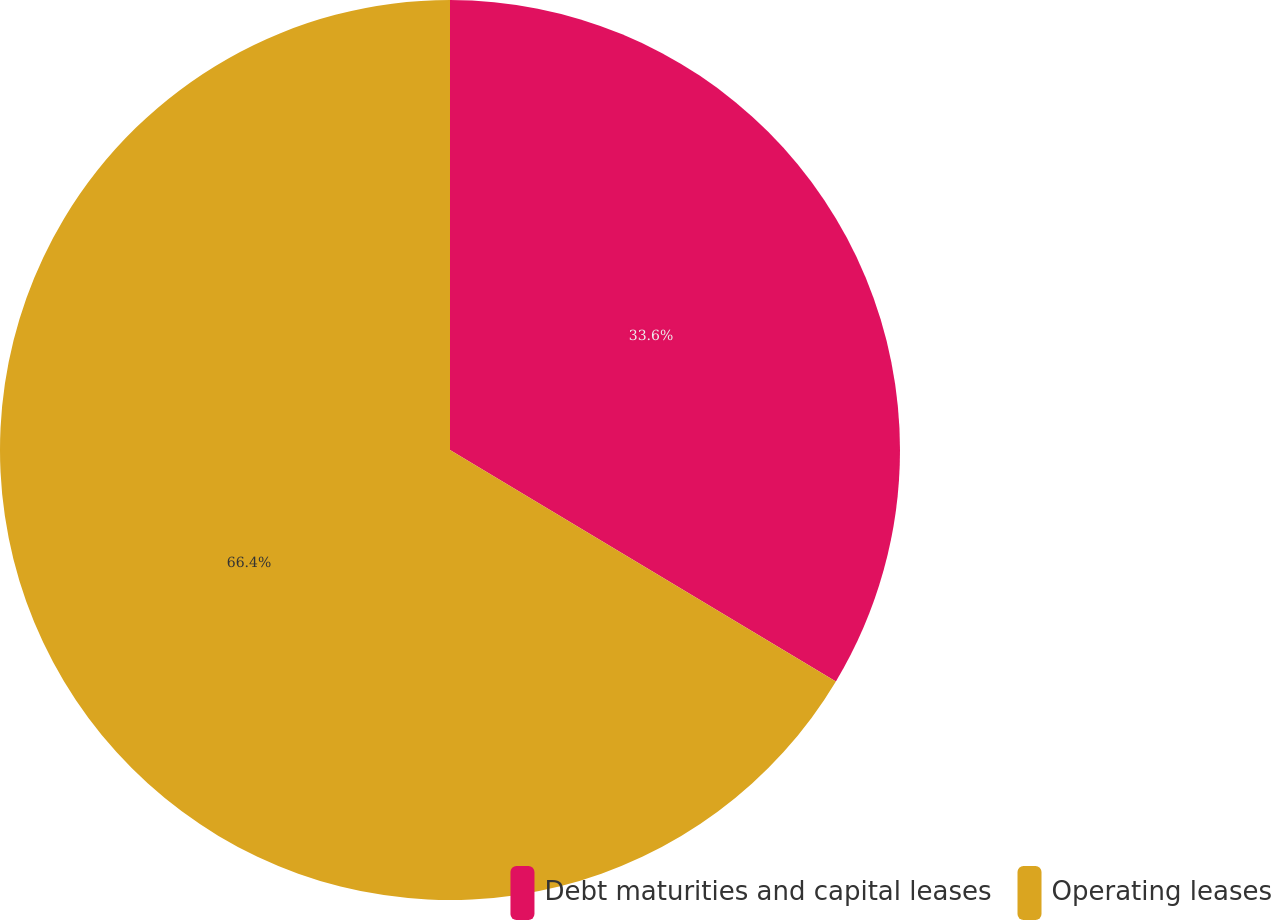Convert chart to OTSL. <chart><loc_0><loc_0><loc_500><loc_500><pie_chart><fcel>Debt maturities and capital leases<fcel>Operating leases<nl><fcel>33.6%<fcel>66.4%<nl></chart> 